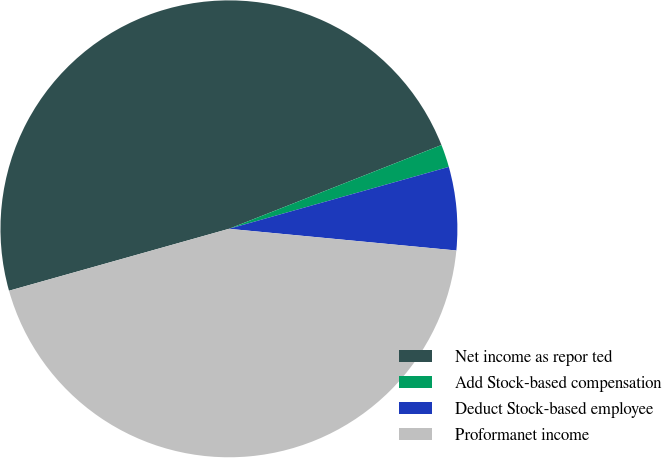Convert chart to OTSL. <chart><loc_0><loc_0><loc_500><loc_500><pie_chart><fcel>Net income as repor ted<fcel>Add Stock-based compensation<fcel>Deduct Stock-based employee<fcel>Proformanet income<nl><fcel>48.39%<fcel>1.61%<fcel>5.88%<fcel>44.12%<nl></chart> 